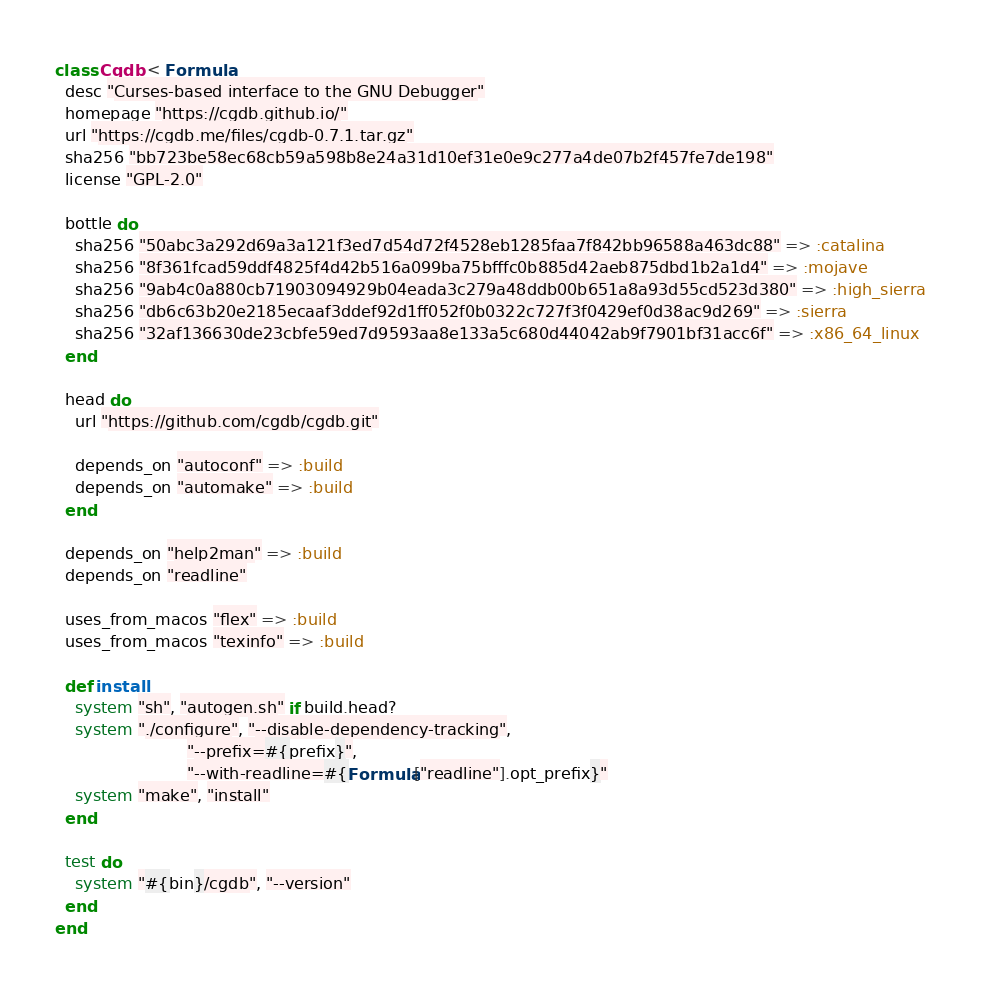Convert code to text. <code><loc_0><loc_0><loc_500><loc_500><_Ruby_>class Cgdb < Formula
  desc "Curses-based interface to the GNU Debugger"
  homepage "https://cgdb.github.io/"
  url "https://cgdb.me/files/cgdb-0.7.1.tar.gz"
  sha256 "bb723be58ec68cb59a598b8e24a31d10ef31e0e9c277a4de07b2f457fe7de198"
  license "GPL-2.0"

  bottle do
    sha256 "50abc3a292d69a3a121f3ed7d54d72f4528eb1285faa7f842bb96588a463dc88" => :catalina
    sha256 "8f361fcad59ddf4825f4d42b516a099ba75bfffc0b885d42aeb875dbd1b2a1d4" => :mojave
    sha256 "9ab4c0a880cb71903094929b04eada3c279a48ddb00b651a8a93d55cd523d380" => :high_sierra
    sha256 "db6c63b20e2185ecaaf3ddef92d1ff052f0b0322c727f3f0429ef0d38ac9d269" => :sierra
    sha256 "32af136630de23cbfe59ed7d9593aa8e133a5c680d44042ab9f7901bf31acc6f" => :x86_64_linux
  end

  head do
    url "https://github.com/cgdb/cgdb.git"

    depends_on "autoconf" => :build
    depends_on "automake" => :build
  end

  depends_on "help2man" => :build
  depends_on "readline"

  uses_from_macos "flex" => :build
  uses_from_macos "texinfo" => :build

  def install
    system "sh", "autogen.sh" if build.head?
    system "./configure", "--disable-dependency-tracking",
                          "--prefix=#{prefix}",
                          "--with-readline=#{Formula["readline"].opt_prefix}"
    system "make", "install"
  end

  test do
    system "#{bin}/cgdb", "--version"
  end
end
</code> 